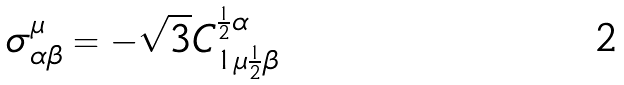Convert formula to latex. <formula><loc_0><loc_0><loc_500><loc_500>\sigma _ { \alpha \beta } ^ { \mu } = - \sqrt { 3 } C _ { 1 \mu { \frac { 1 } { 2 } } \beta } ^ { { \frac { 1 } { 2 } } \alpha }</formula> 